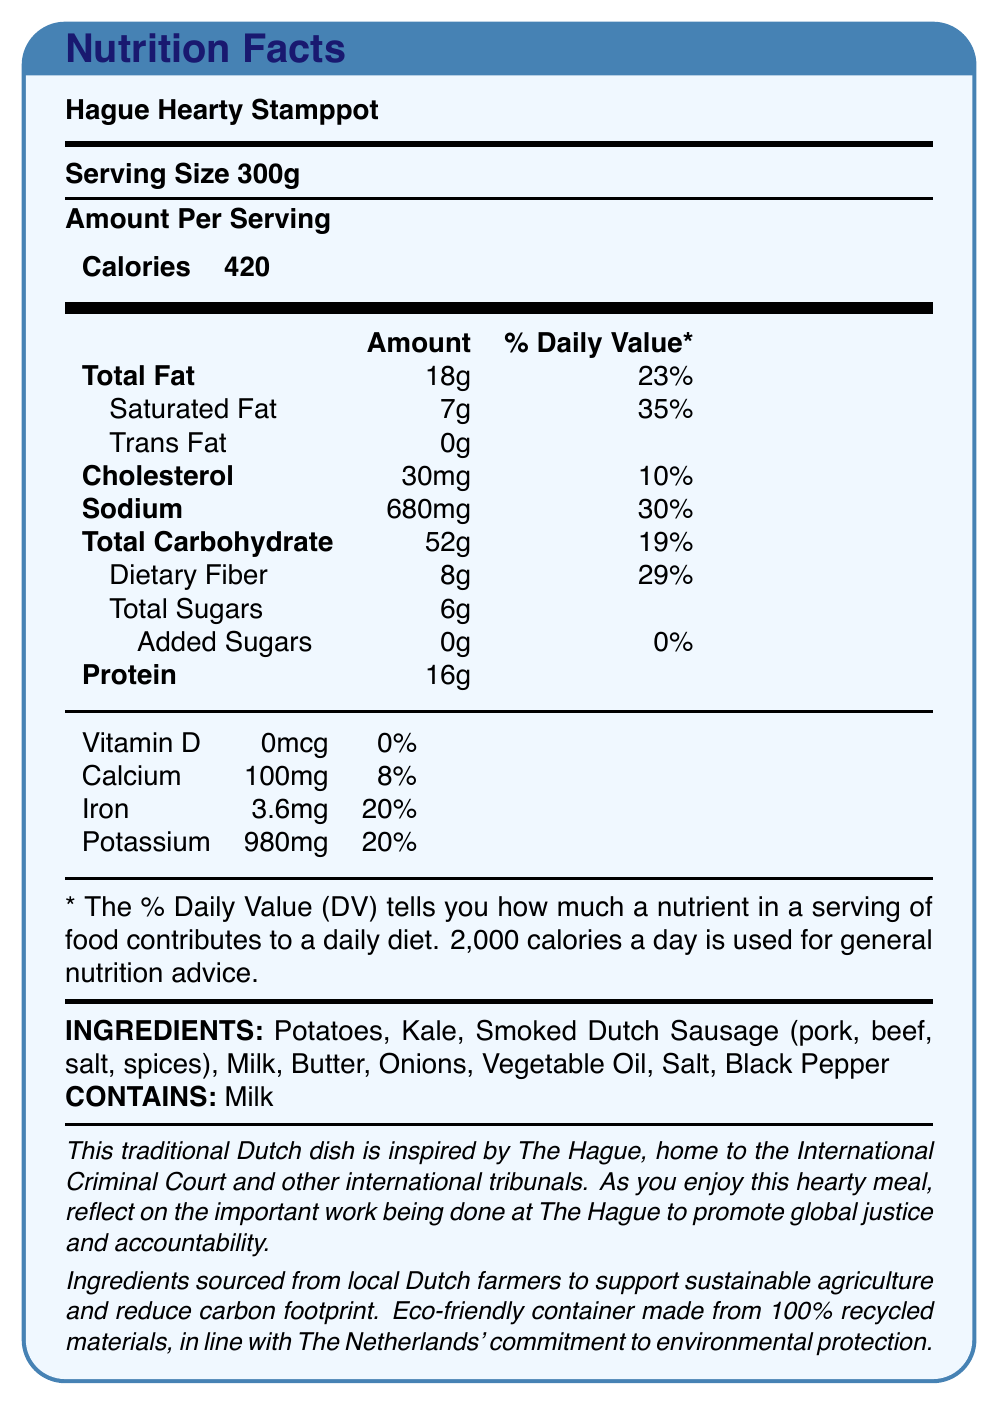what is the serving size? The document states that the serving size for the Hague Hearty Stamppot is 300g.
Answer: 300g how many calories are in one serving? According to the document, one serving contains 420 calories.
Answer: 420 what is the total fat content and its daily value percentage? The document lists the total fat content as 18g and the daily value percentage as 23%.
Answer: 18g, 23% what percentage of the daily value for saturated fat does one serving of this meal contain? The document shows that one serving contains 7g of saturated fat, which is 35% of the daily value.
Answer: 35% how much dietary fiber does one serving provide? The document indicates that one serving includes 8g of dietary fiber.
Answer: 8g what is the source of inspiration for this dish? The document states that this traditional Dutch dish is inspired by The Hague.
Answer: The Hague, home to the International Criminal Court and other international tribunals which nutrient has the highest daily value percentage in this meal? A. Sodium B. Saturated Fat C. Dietary Fiber D. Total Fat Saturated fat has a daily value percentage of 35%, which is higher than the other nutrients listed.
Answer: B. Saturated Fat what does "DV" stand for in the context of the nutrition label? A. Dietary Value B. Daily Value C. Diverse Value D. Diet Value The document explains that DV stands for Daily Value.
Answer: B. Daily Value does this product contain any added sugars? The document specifies that the product contains 0g of added sugars, which is 0% of the daily value.
Answer: No is this meal eco-friendly? The document mentions that the packaging is made from 100% recycled materials and that ingredients are sourced from local Dutch farmers to support sustainable agriculture.
Answer: Yes does this product contain milk? In the allergens section of the document, milk is listed as an ingredient that the product contains.
Answer: Yes describe the main idea of this document. The document provides comprehensive information about the nutritional content and thematic inspiration of the Hague Hearty Stamppot, focusing on both dietary aspects and values of sustainability and global justice.
Answer: This document is a Nutrition Facts label for a ready-meal called Hague Hearty Stamppot. It details the serving size, nutrient content, daily value percentages, ingredients, and allergens. The meal draws inspiration from The Hague, highlighting the work of international tribunals in promoting global justice and accountability. It also emphasizes sustainability by sourcing local ingredients and using eco-friendly packaging. what is the total amount of protein in the meal? The document states that one serving of the meal contains 16g of protein.
Answer: 16g can the exact proportions of pork and beef in the smoked Dutch sausage be determined from this document? The document lists "Smoked Dutch Sausage (pork, beef, salt, spices)" as an ingredient, but does not specify the proportions of pork and beef.
Answer: Not enough information 